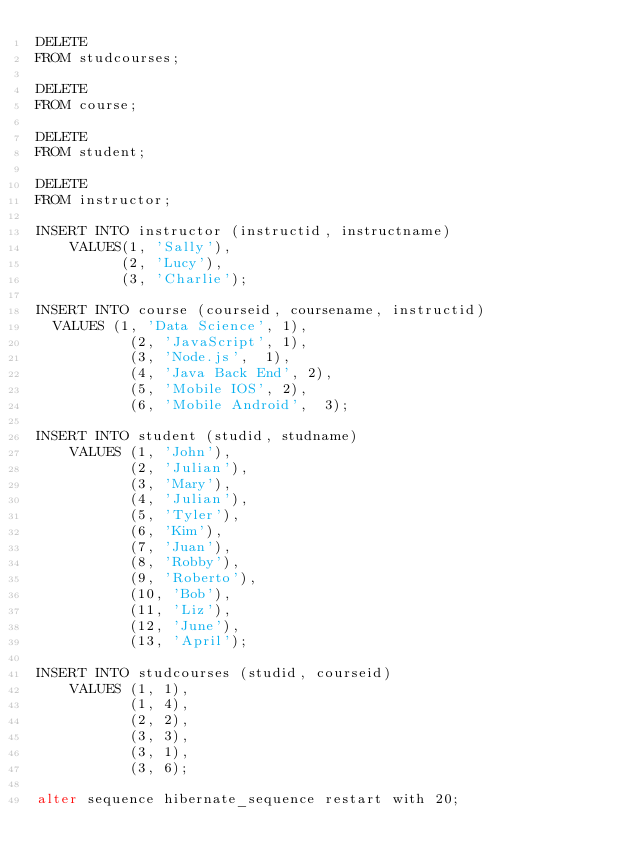<code> <loc_0><loc_0><loc_500><loc_500><_SQL_>DELETE
FROM studcourses;

DELETE
FROM course;

DELETE
FROM student;

DELETE
FROM instructor;

INSERT INTO instructor (instructid, instructname)
    VALUES(1, 'Sally'),
          (2, 'Lucy'),
          (3, 'Charlie');

INSERT INTO course (courseid, coursename, instructid)
	VALUES (1, 'Data Science', 1),
           (2, 'JavaScript', 1),
           (3, 'Node.js',  1),
           (4, 'Java Back End', 2),
           (5, 'Mobile IOS', 2),
           (6, 'Mobile Android',  3);

INSERT INTO student (studid, studname)
    VALUES (1, 'John'),
           (2, 'Julian'),
           (3, 'Mary'),
           (4, 'Julian'),
           (5, 'Tyler'),
           (6, 'Kim'),
           (7, 'Juan'),
           (8, 'Robby'),
           (9, 'Roberto'),
           (10, 'Bob'),
           (11, 'Liz'),
           (12, 'June'),
           (13, 'April');

INSERT INTO studcourses (studid, courseid)
    VALUES (1, 1),
           (1, 4),
           (2, 2),
           (3, 3),
           (3, 1),
           (3, 6);

alter sequence hibernate_sequence restart with 20;</code> 